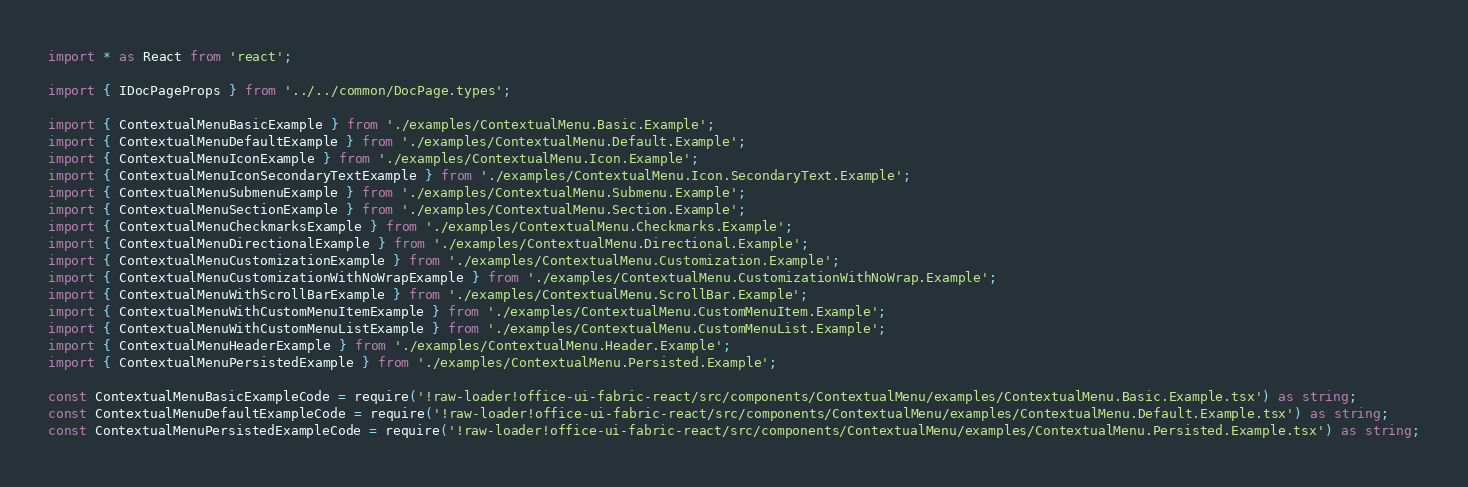Convert code to text. <code><loc_0><loc_0><loc_500><loc_500><_TypeScript_>import * as React from 'react';

import { IDocPageProps } from '../../common/DocPage.types';

import { ContextualMenuBasicExample } from './examples/ContextualMenu.Basic.Example';
import { ContextualMenuDefaultExample } from './examples/ContextualMenu.Default.Example';
import { ContextualMenuIconExample } from './examples/ContextualMenu.Icon.Example';
import { ContextualMenuIconSecondaryTextExample } from './examples/ContextualMenu.Icon.SecondaryText.Example';
import { ContextualMenuSubmenuExample } from './examples/ContextualMenu.Submenu.Example';
import { ContextualMenuSectionExample } from './examples/ContextualMenu.Section.Example';
import { ContextualMenuCheckmarksExample } from './examples/ContextualMenu.Checkmarks.Example';
import { ContextualMenuDirectionalExample } from './examples/ContextualMenu.Directional.Example';
import { ContextualMenuCustomizationExample } from './examples/ContextualMenu.Customization.Example';
import { ContextualMenuCustomizationWithNoWrapExample } from './examples/ContextualMenu.CustomizationWithNoWrap.Example';
import { ContextualMenuWithScrollBarExample } from './examples/ContextualMenu.ScrollBar.Example';
import { ContextualMenuWithCustomMenuItemExample } from './examples/ContextualMenu.CustomMenuItem.Example';
import { ContextualMenuWithCustomMenuListExample } from './examples/ContextualMenu.CustomMenuList.Example';
import { ContextualMenuHeaderExample } from './examples/ContextualMenu.Header.Example';
import { ContextualMenuPersistedExample } from './examples/ContextualMenu.Persisted.Example';

const ContextualMenuBasicExampleCode = require('!raw-loader!office-ui-fabric-react/src/components/ContextualMenu/examples/ContextualMenu.Basic.Example.tsx') as string;
const ContextualMenuDefaultExampleCode = require('!raw-loader!office-ui-fabric-react/src/components/ContextualMenu/examples/ContextualMenu.Default.Example.tsx') as string;
const ContextualMenuPersistedExampleCode = require('!raw-loader!office-ui-fabric-react/src/components/ContextualMenu/examples/ContextualMenu.Persisted.Example.tsx') as string;</code> 